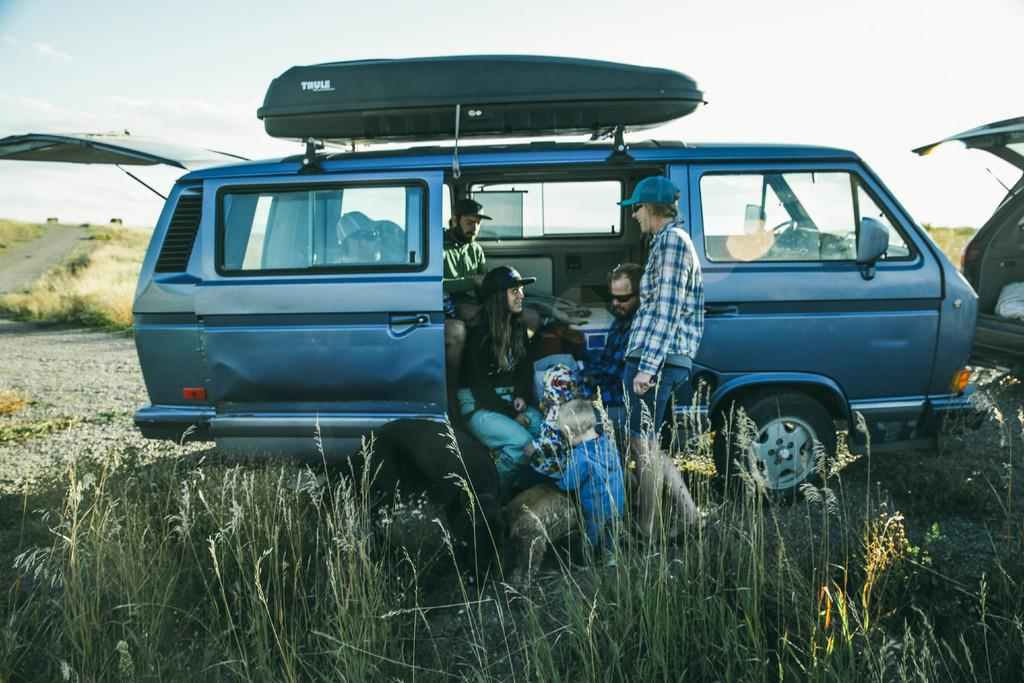How many people are in the image? There are persons in the image, but the exact number is not specified. What else can be seen on the ground besides the persons? There are vehicles on the ground in the image. What type of surface is visible in the image? There is a road in the image. What type of vegetation is visible in the image? There is grass visible in the image. What is visible in the background of the image? The sky is visible in the background of the image. What type of haircut is the person on the side of the image getting? There is no person getting a haircut in the image, nor is there any mention of a haircut or a person on the side of the image. 